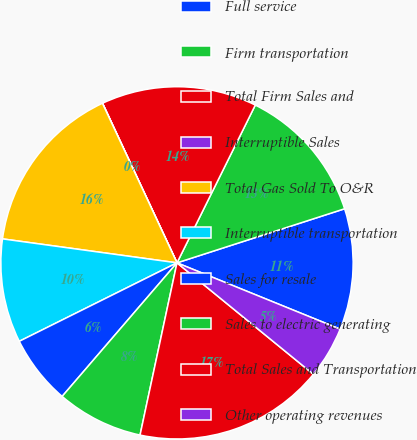<chart> <loc_0><loc_0><loc_500><loc_500><pie_chart><fcel>Full service<fcel>Firm transportation<fcel>Total Firm Sales and<fcel>Interruptible Sales<fcel>Total Gas Sold To O&R<fcel>Interruptible transportation<fcel>Sales for resale<fcel>Sales to electric generating<fcel>Total Sales and Transportation<fcel>Other operating revenues<nl><fcel>11.11%<fcel>12.7%<fcel>14.28%<fcel>0.01%<fcel>15.87%<fcel>9.52%<fcel>6.35%<fcel>7.94%<fcel>17.46%<fcel>4.76%<nl></chart> 